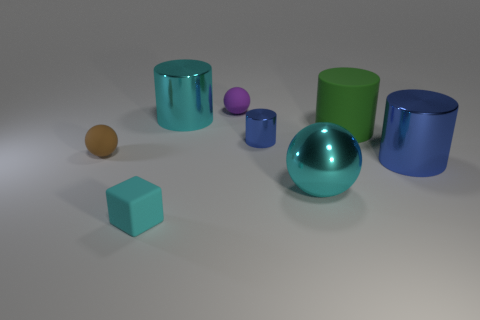Does the small blue object have the same material as the large cyan thing that is to the left of the purple object?
Offer a terse response. Yes. How many tiny purple spheres are right of the shiny cylinder in front of the tiny object to the right of the purple object?
Give a very brief answer. 0. How many blue objects are shiny objects or tiny metallic objects?
Give a very brief answer. 2. The big cyan metal thing to the left of the tiny blue cylinder has what shape?
Offer a terse response. Cylinder. There is a sphere that is the same size as the green cylinder; what color is it?
Your answer should be compact. Cyan. Do the purple thing and the rubber object on the right side of the small blue metallic object have the same shape?
Make the answer very short. No. The cylinder to the left of the blue shiny thing behind the object that is on the right side of the green thing is made of what material?
Give a very brief answer. Metal. What number of tiny things are blue shiny objects or metal objects?
Your response must be concise. 1. How many other things are there of the same size as the cyan block?
Offer a very short reply. 3. There is a cyan object that is behind the small blue thing; is its shape the same as the large blue object?
Provide a short and direct response. Yes. 